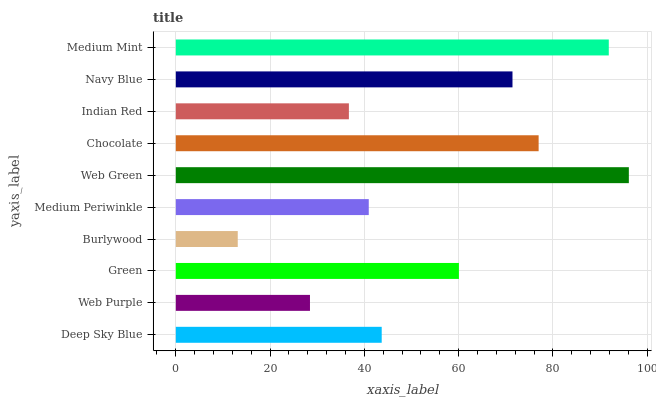Is Burlywood the minimum?
Answer yes or no. Yes. Is Web Green the maximum?
Answer yes or no. Yes. Is Web Purple the minimum?
Answer yes or no. No. Is Web Purple the maximum?
Answer yes or no. No. Is Deep Sky Blue greater than Web Purple?
Answer yes or no. Yes. Is Web Purple less than Deep Sky Blue?
Answer yes or no. Yes. Is Web Purple greater than Deep Sky Blue?
Answer yes or no. No. Is Deep Sky Blue less than Web Purple?
Answer yes or no. No. Is Green the high median?
Answer yes or no. Yes. Is Deep Sky Blue the low median?
Answer yes or no. Yes. Is Chocolate the high median?
Answer yes or no. No. Is Web Green the low median?
Answer yes or no. No. 